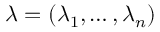<formula> <loc_0><loc_0><loc_500><loc_500>\lambda = ( \lambda _ { 1 } , \dots , \lambda _ { n } )</formula> 